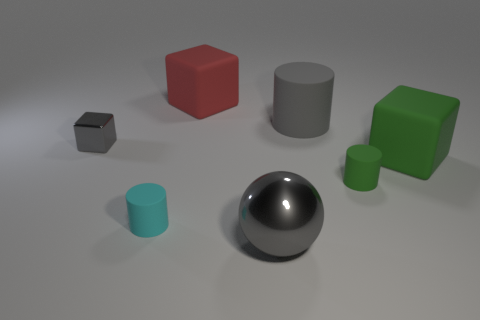How many cyan metallic cubes are there?
Your response must be concise. 0. Does the big green thing have the same material as the large gray object behind the large green matte cube?
Make the answer very short. Yes. There is a big cylinder that is the same color as the ball; what is it made of?
Make the answer very short. Rubber. What number of tiny metallic cylinders have the same color as the small shiny thing?
Make the answer very short. 0. What is the size of the gray shiny block?
Provide a succinct answer. Small. Does the large gray matte object have the same shape as the tiny object that is right of the cyan thing?
Provide a succinct answer. Yes. What color is the tiny cube that is made of the same material as the large ball?
Your answer should be very brief. Gray. There is a block behind the gray metallic cube; what is its size?
Keep it short and to the point. Large. Are there fewer green cylinders that are in front of the large ball than cylinders?
Your answer should be very brief. Yes. Is the color of the metal ball the same as the small cube?
Provide a succinct answer. Yes. 